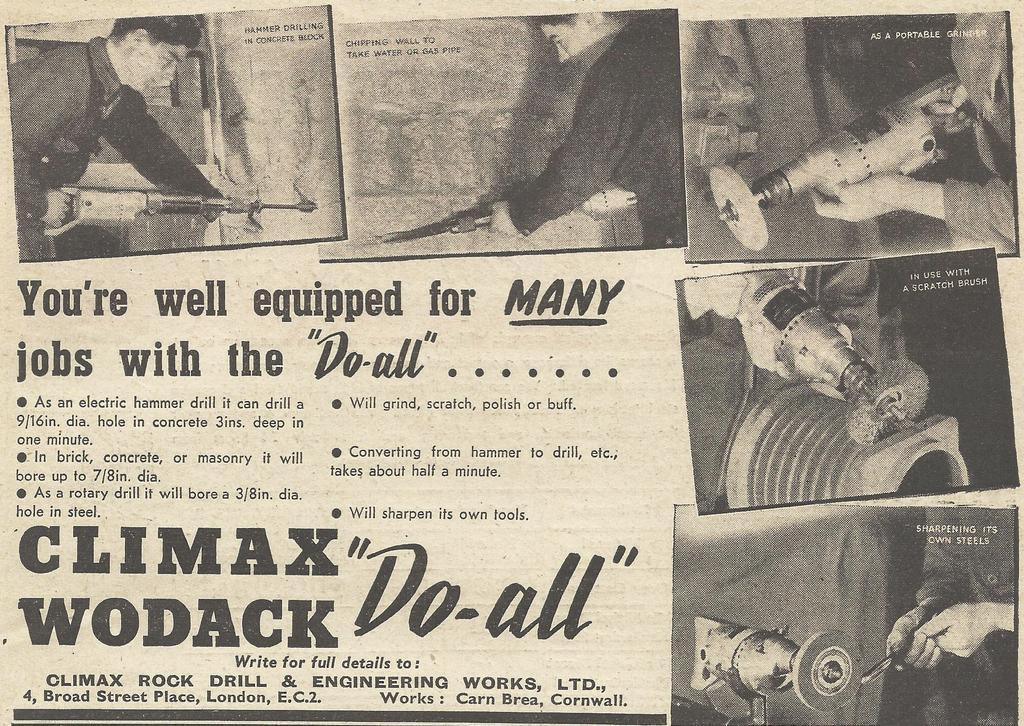Describe this image in one or two sentences. In this image we can see a paper and there are pictures. We can see a man holding a driller and there is text. 